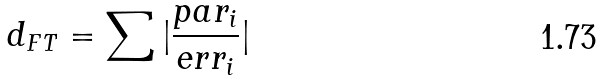<formula> <loc_0><loc_0><loc_500><loc_500>d _ { F T } = \sum | \frac { p a r _ { i } } { e r r _ { i } } |</formula> 